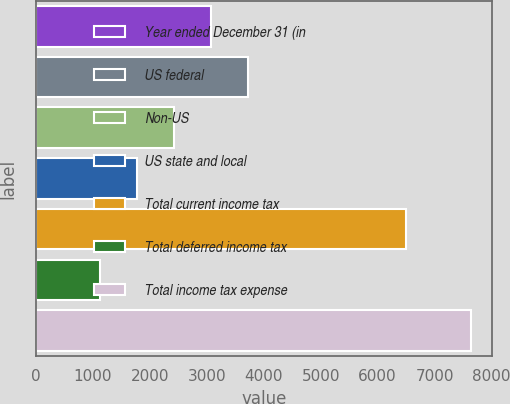<chart> <loc_0><loc_0><loc_500><loc_500><bar_chart><fcel>Year ended December 31 (in<fcel>US federal<fcel>Non-US<fcel>US state and local<fcel>Total current income tax<fcel>Total deferred income tax<fcel>Total income tax expense<nl><fcel>3080.9<fcel>3731.2<fcel>2430.6<fcel>1780.3<fcel>6503<fcel>1130<fcel>7633<nl></chart> 